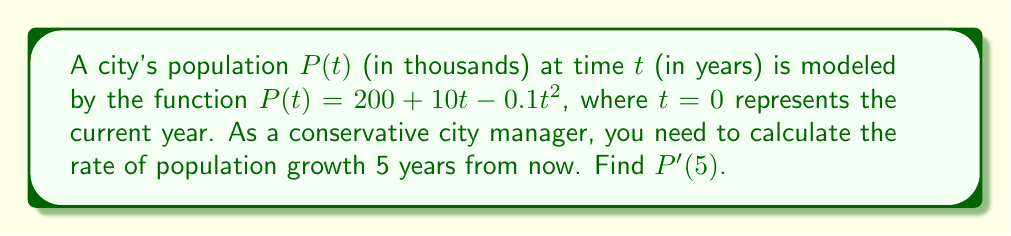Teach me how to tackle this problem. To solve this problem, we need to follow these steps:

1) The rate of population growth is represented by the derivative of the population function $P(t)$.

2) To find $P'(t)$, we need to differentiate $P(t)$ with respect to $t$:

   $P(t) = 200 + 10t - 0.1t^2$
   
   $P'(t) = 10 - 0.2t$ (using the power rule of differentiation)

3) We're asked to find the rate of growth 5 years from now, so we need to calculate $P'(5)$:

   $P'(5) = 10 - 0.2(5)$
   
   $P'(5) = 10 - 1 = 9$

4) Interpret the result: The rate of population growth 5 years from now will be 9 thousand people per year.

As a conservative city manager, this information helps in cautious planning for future resources and infrastructure needs.
Answer: $9$ thousand per year 